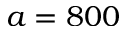Convert formula to latex. <formula><loc_0><loc_0><loc_500><loc_500>a = 8 0 0</formula> 